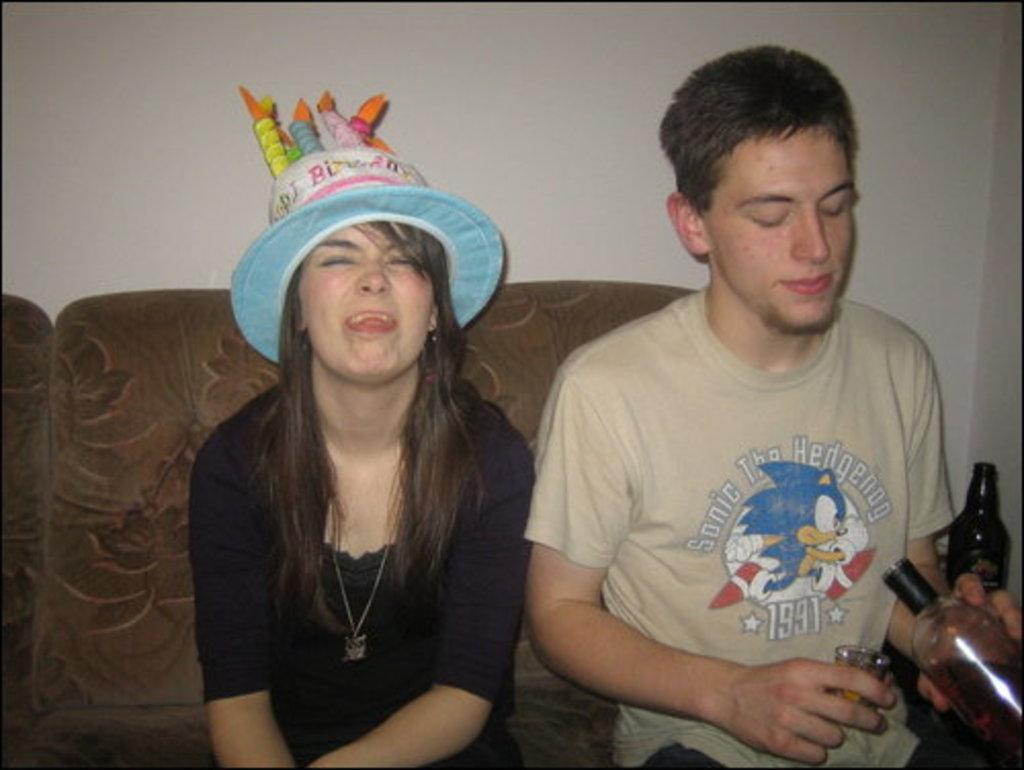Who are the people in the image? There is a guy and a lady in the image. What are they doing in the image? Both the guy and the lady are sitting on a sofa. What is the guy holding in his hand? The guy is holding a glass bottle in his hand. What can be seen on the lady's head? The girl is wearing a "Happy Birthday" cap. Can you tell me how many horses are present in the image? There are no horses present in the image. What does the lady express towards the guy in the image? The image does not show any expressions of hate or any other emotions between the guy and the lady. 